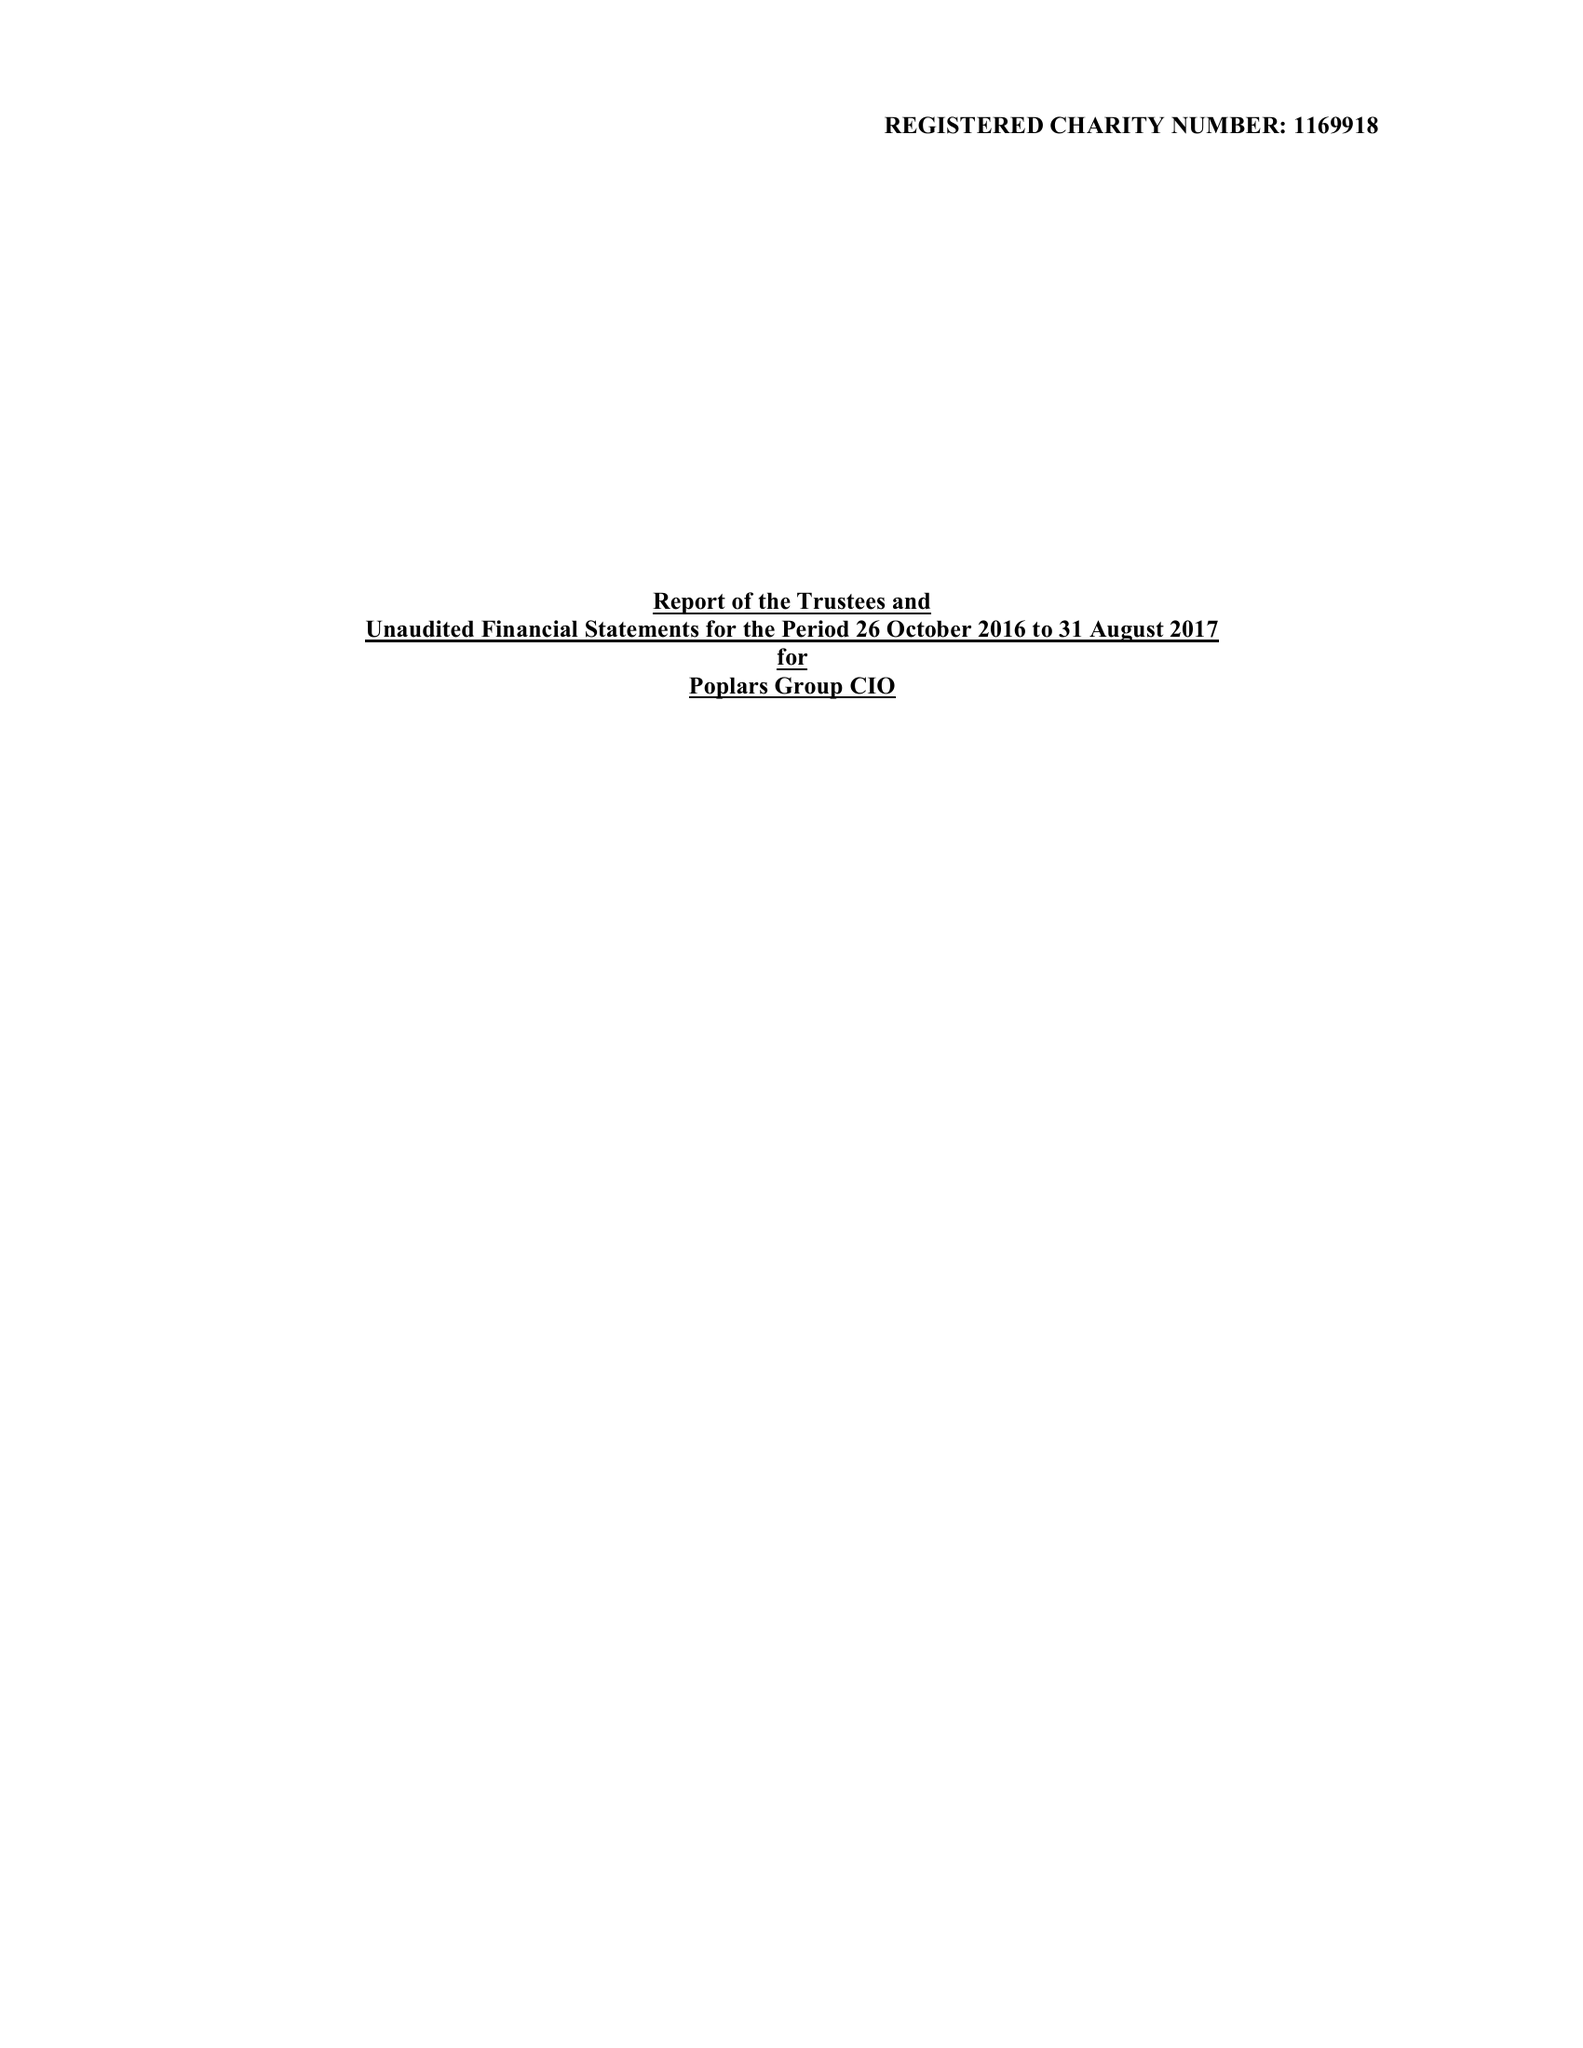What is the value for the charity_number?
Answer the question using a single word or phrase. 1169918 